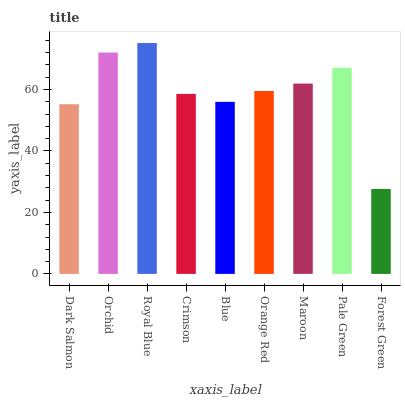Is Orchid the minimum?
Answer yes or no. No. Is Orchid the maximum?
Answer yes or no. No. Is Orchid greater than Dark Salmon?
Answer yes or no. Yes. Is Dark Salmon less than Orchid?
Answer yes or no. Yes. Is Dark Salmon greater than Orchid?
Answer yes or no. No. Is Orchid less than Dark Salmon?
Answer yes or no. No. Is Orange Red the high median?
Answer yes or no. Yes. Is Orange Red the low median?
Answer yes or no. Yes. Is Dark Salmon the high median?
Answer yes or no. No. Is Blue the low median?
Answer yes or no. No. 